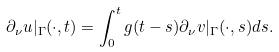<formula> <loc_0><loc_0><loc_500><loc_500>\partial _ { \nu } u | _ { \Gamma } ( \cdot , t ) = \int _ { 0 } ^ { t } g ( t - s ) \partial _ { \nu } v | _ { \Gamma } ( \cdot , s ) d s .</formula> 